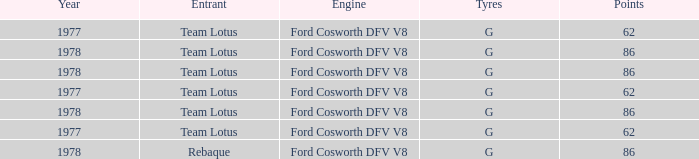What is the Focus that has a Year bigger than 1977? 86, 86, 86, 86. 